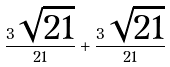<formula> <loc_0><loc_0><loc_500><loc_500>\frac { 3 \sqrt { 2 1 } } { 2 1 } + \frac { 3 \sqrt { 2 1 } } { 2 1 }</formula> 